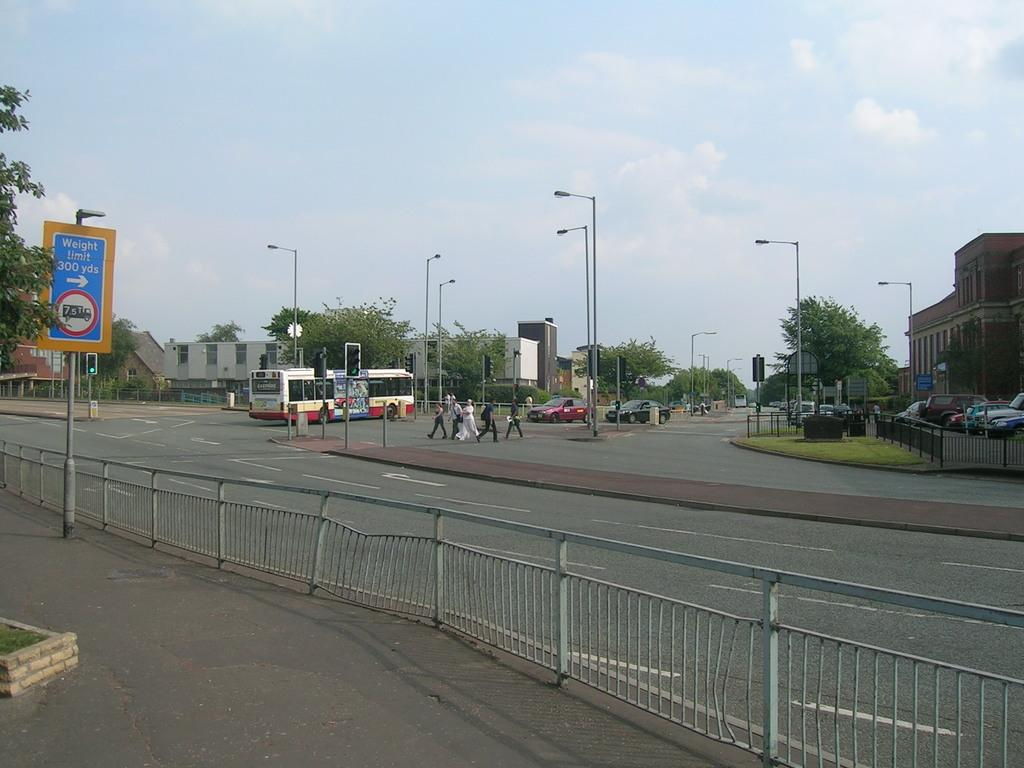<image>
Provide a brief description of the given image. A road sign cautions of a weight limit in effect 300 yards away. 